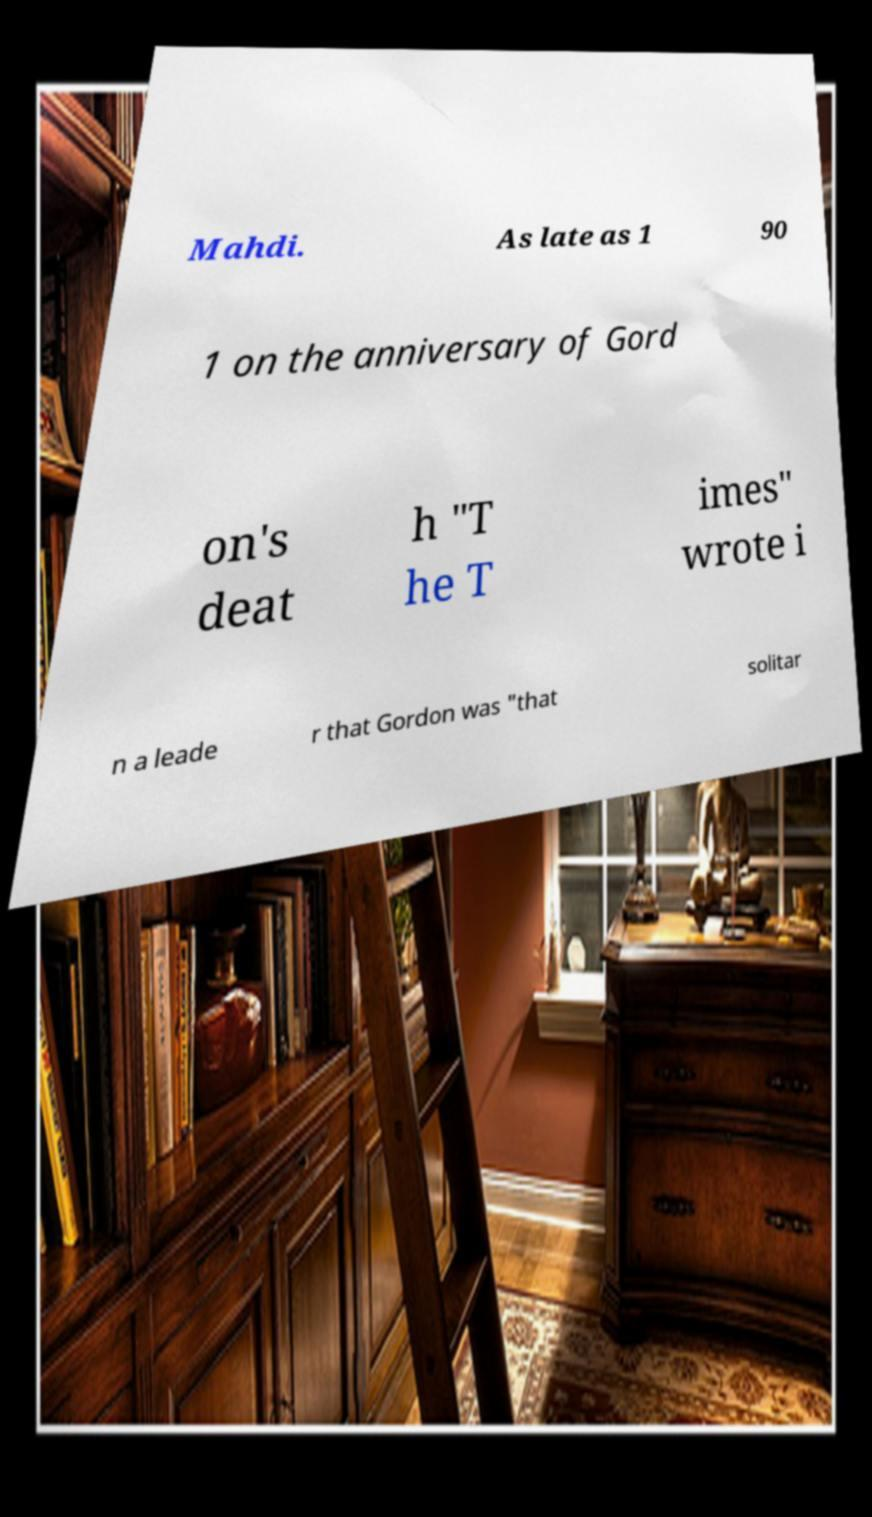Please identify and transcribe the text found in this image. Mahdi. As late as 1 90 1 on the anniversary of Gord on's deat h "T he T imes" wrote i n a leade r that Gordon was "that solitar 